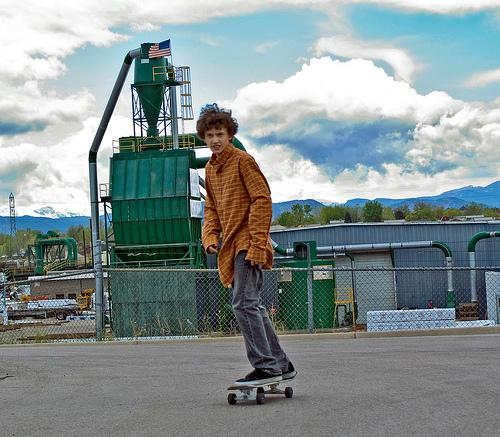Question: where is the boy at?
Choices:
A. A skate park.
B. An amusement park.
C. The street.
D. A parking lot.
Answer with the letter. Answer: D Question: what is he riding?
Choices:
A. A bicycle.
B. A motorbike.
C. A snowboard.
D. A skateboard.
Answer with the letter. Answer: D Question: who is he with?
Choices:
A. He is alone.
B. He is with another boy.
C. He is with a girl.
D. He is with a woman.
Answer with the letter. Answer: A Question: why is he there?
Choices:
A. To take a break.
B. Because he is waiting for someone.
C. To ride his skateboard.
D. Because his car needs repair.
Answer with the letter. Answer: C Question: what is above him?
Choices:
A. The ceiling.
B. Clouds.
C. A doorway.
D. The sky.
Answer with the letter. Answer: D 